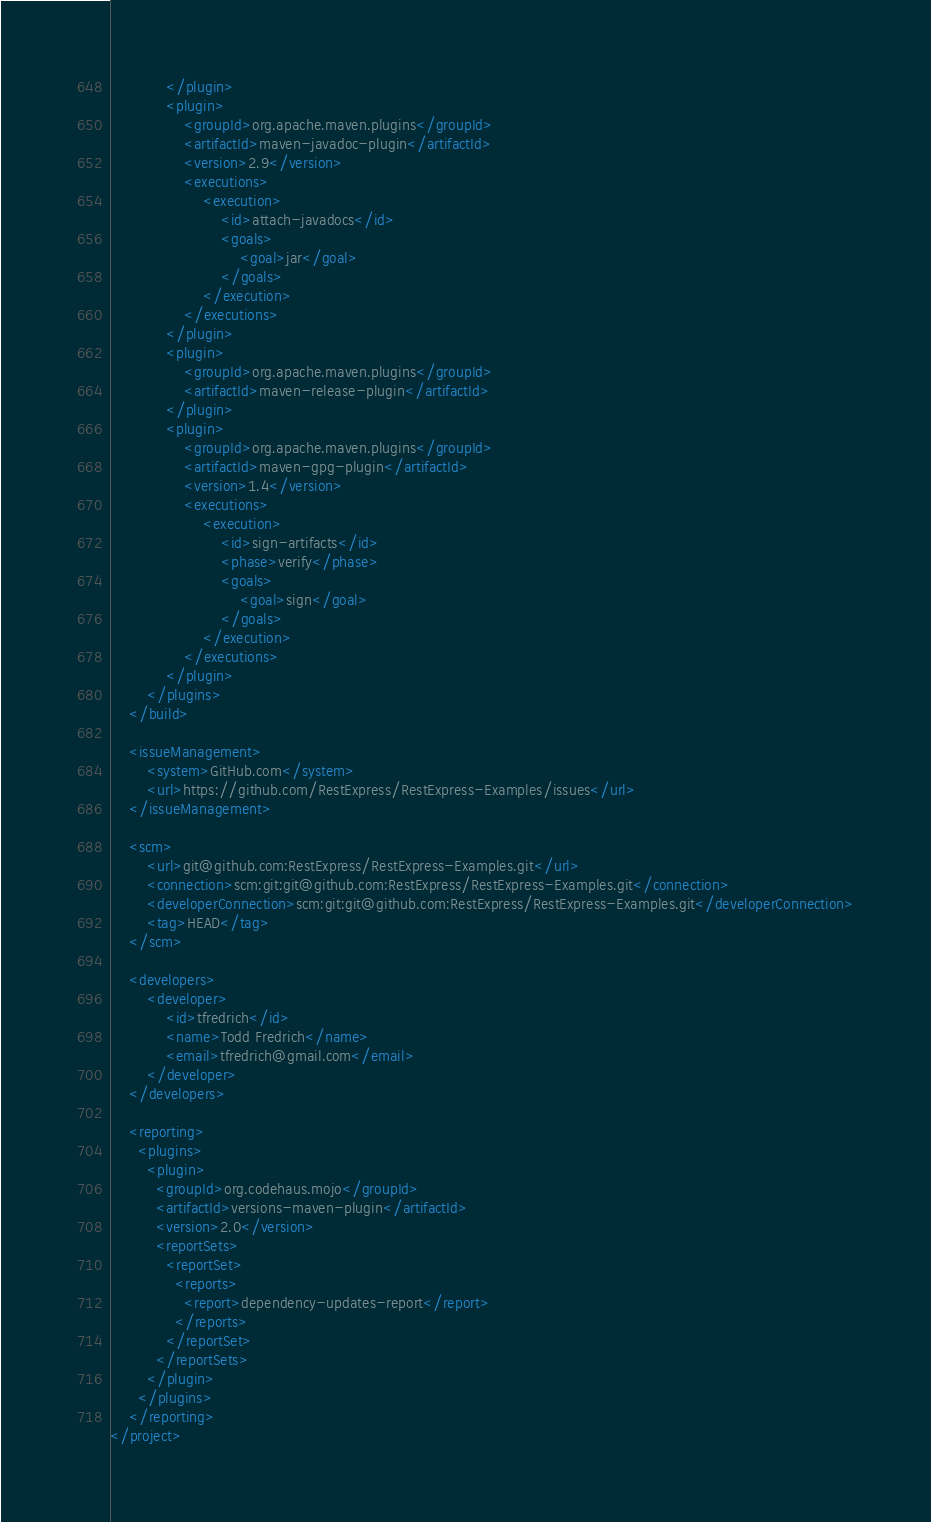<code> <loc_0><loc_0><loc_500><loc_500><_XML_>			</plugin>
			<plugin>
				<groupId>org.apache.maven.plugins</groupId>
				<artifactId>maven-javadoc-plugin</artifactId>
				<version>2.9</version>
				<executions>
					<execution>
						<id>attach-javadocs</id>
						<goals>
							<goal>jar</goal>
						</goals>
					</execution>
				</executions>
			</plugin>
			<plugin>
				<groupId>org.apache.maven.plugins</groupId>
				<artifactId>maven-release-plugin</artifactId>
			</plugin>
			<plugin>
				<groupId>org.apache.maven.plugins</groupId>
				<artifactId>maven-gpg-plugin</artifactId>
				<version>1.4</version>
				<executions>
					<execution>
						<id>sign-artifacts</id>
						<phase>verify</phase>
						<goals>
							<goal>sign</goal>
						</goals>
					</execution>
				</executions>
			</plugin>
		</plugins>
	</build>

	<issueManagement>
		<system>GitHub.com</system>
		<url>https://github.com/RestExpress/RestExpress-Examples/issues</url>
	</issueManagement>

	<scm>
		<url>git@github.com:RestExpress/RestExpress-Examples.git</url>
		<connection>scm:git:git@github.com:RestExpress/RestExpress-Examples.git</connection>
		<developerConnection>scm:git:git@github.com:RestExpress/RestExpress-Examples.git</developerConnection>
		<tag>HEAD</tag>
	</scm>

	<developers>
		<developer>
			<id>tfredrich</id>
			<name>Todd Fredrich</name>
			<email>tfredrich@gmail.com</email>
		</developer>
	</developers>

	<reporting>
	  <plugins>
		<plugin>
		  <groupId>org.codehaus.mojo</groupId>
		  <artifactId>versions-maven-plugin</artifactId>
		  <version>2.0</version>
		  <reportSets>
			<reportSet>
			  <reports>
				<report>dependency-updates-report</report>
			  </reports>
			</reportSet>
		  </reportSets>
		</plugin>
	  </plugins>
	</reporting>
</project>
</code> 